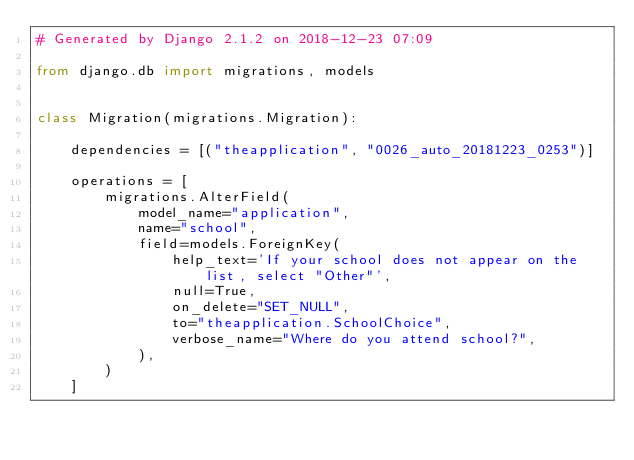Convert code to text. <code><loc_0><loc_0><loc_500><loc_500><_Python_># Generated by Django 2.1.2 on 2018-12-23 07:09

from django.db import migrations, models


class Migration(migrations.Migration):

    dependencies = [("theapplication", "0026_auto_20181223_0253")]

    operations = [
        migrations.AlterField(
            model_name="application",
            name="school",
            field=models.ForeignKey(
                help_text='If your school does not appear on the list, select "Other"',
                null=True,
                on_delete="SET_NULL",
                to="theapplication.SchoolChoice",
                verbose_name="Where do you attend school?",
            ),
        )
    ]
</code> 